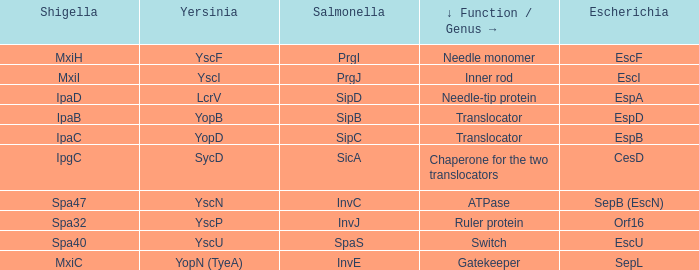Tell me the shigella for yersinia yopb IpaB. 